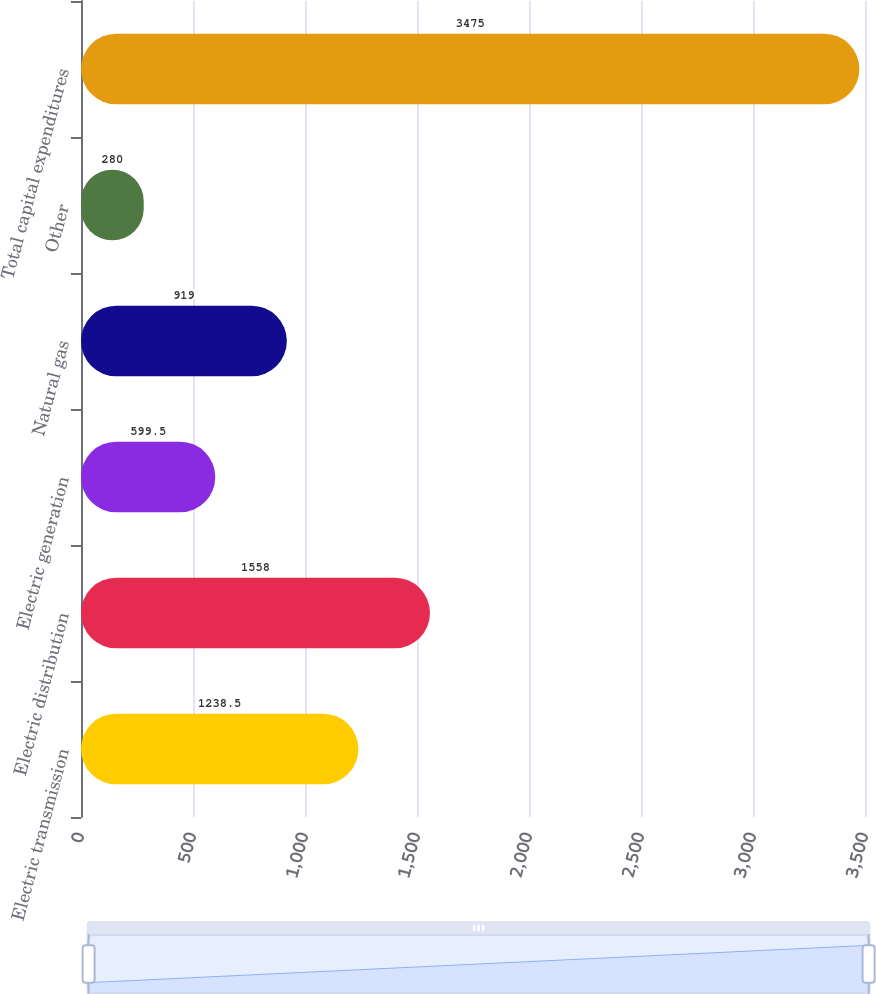<chart> <loc_0><loc_0><loc_500><loc_500><bar_chart><fcel>Electric transmission<fcel>Electric distribution<fcel>Electric generation<fcel>Natural gas<fcel>Other<fcel>Total capital expenditures<nl><fcel>1238.5<fcel>1558<fcel>599.5<fcel>919<fcel>280<fcel>3475<nl></chart> 